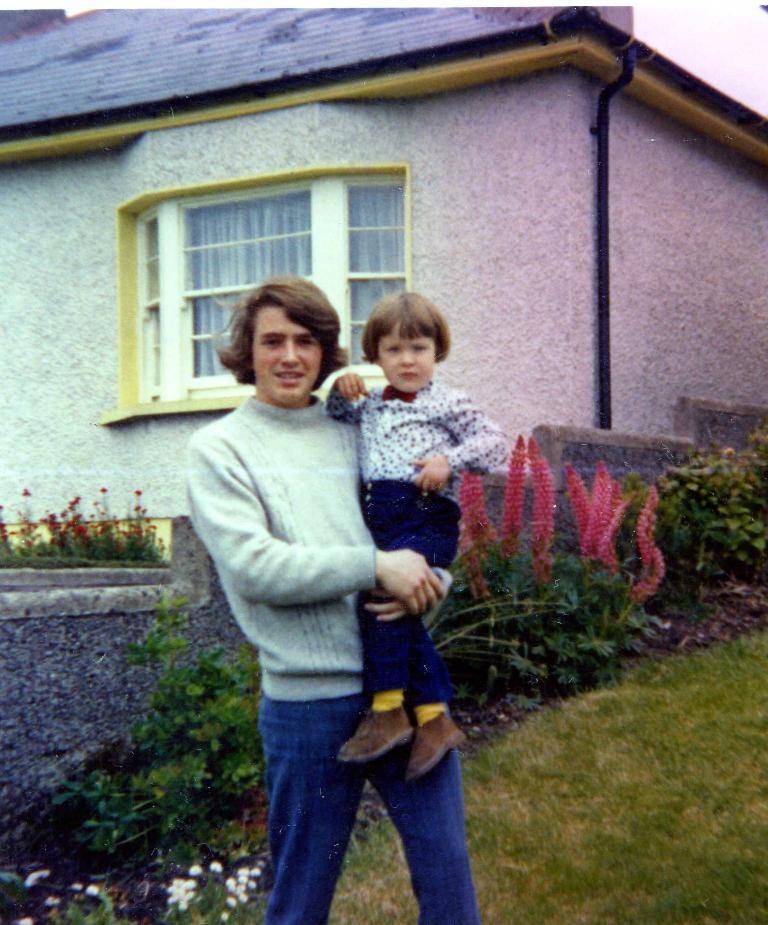Describe this image in one or two sentences. In this image, we can see a person is carrying a kid. Background we can see plants, grass, flowers, wall, house, glass windows, curtains, pipes. 